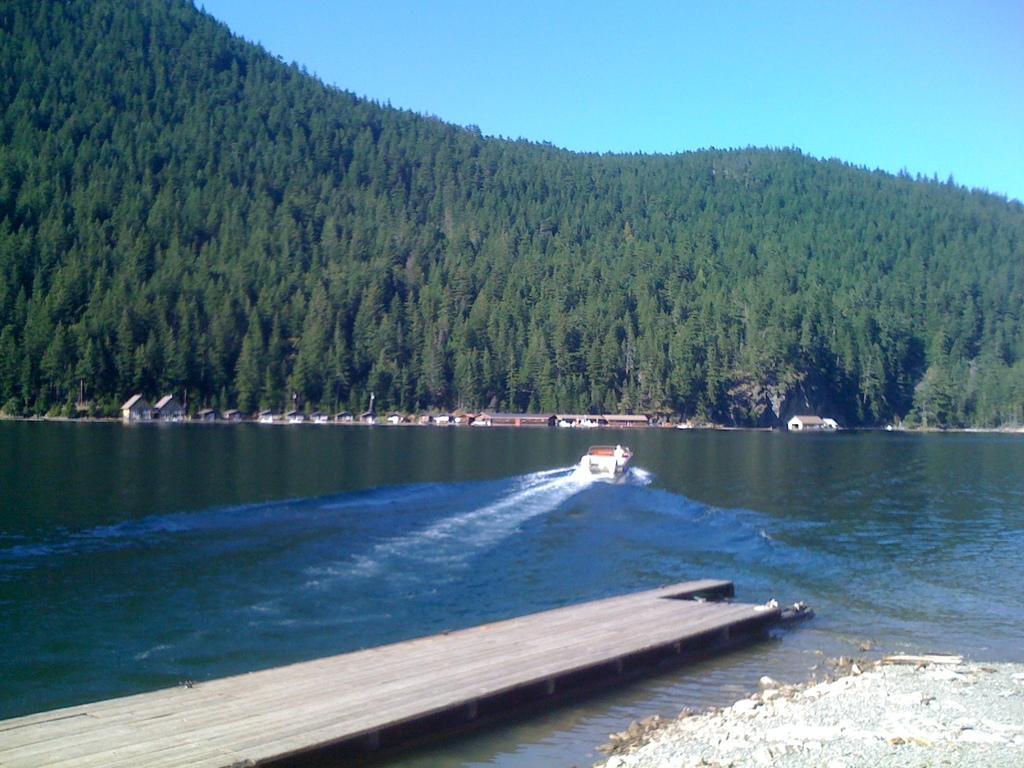Could you give a brief overview of what you see in this image? In this picture we can see the platform, where we can see a boat on water and in the background we can see sheds, trees and the sky. 